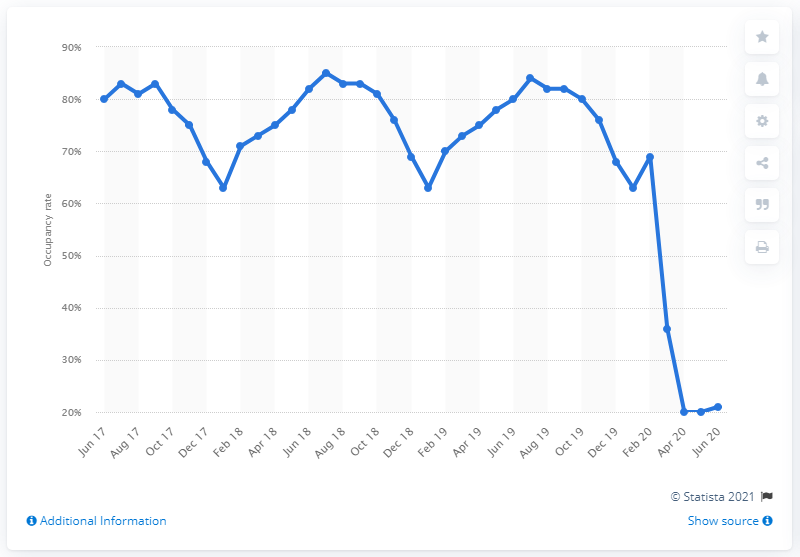Highlight a few significant elements in this photo. In June 2020, approximately 78% of the rooms in serviced accommodation establishments in the UK were occupied. 